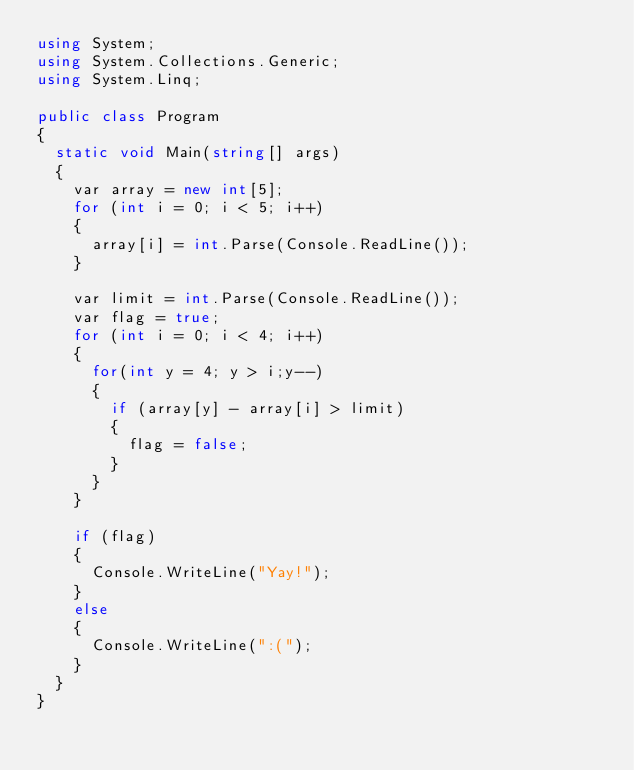<code> <loc_0><loc_0><loc_500><loc_500><_C#_>using System;
using System.Collections.Generic;
using System.Linq;

public class Program
{
	static void Main(string[] args)
	{
		var array = new int[5];
		for (int i = 0; i < 5; i++)
		{
			array[i] = int.Parse(Console.ReadLine());
		}

		var limit = int.Parse(Console.ReadLine());
		var flag = true;
		for (int i = 0; i < 4; i++)
		{
			for(int y = 4; y > i;y--)
			{
				if (array[y] - array[i] > limit)
				{
					flag = false;
				}
			}
		}

		if (flag)
		{
			Console.WriteLine("Yay!");
		}
		else
		{
			Console.WriteLine(":(");
		}
	}
}
</code> 